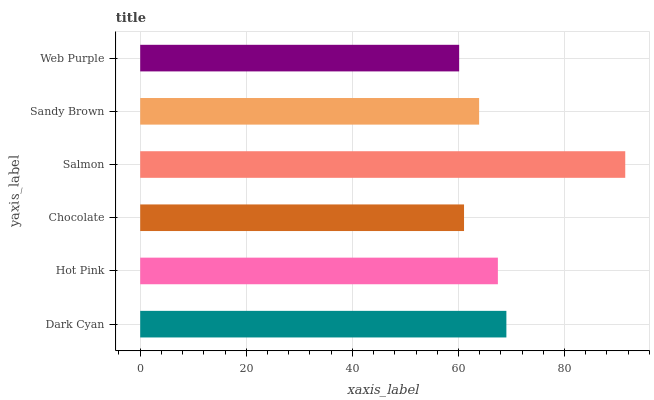Is Web Purple the minimum?
Answer yes or no. Yes. Is Salmon the maximum?
Answer yes or no. Yes. Is Hot Pink the minimum?
Answer yes or no. No. Is Hot Pink the maximum?
Answer yes or no. No. Is Dark Cyan greater than Hot Pink?
Answer yes or no. Yes. Is Hot Pink less than Dark Cyan?
Answer yes or no. Yes. Is Hot Pink greater than Dark Cyan?
Answer yes or no. No. Is Dark Cyan less than Hot Pink?
Answer yes or no. No. Is Hot Pink the high median?
Answer yes or no. Yes. Is Sandy Brown the low median?
Answer yes or no. Yes. Is Chocolate the high median?
Answer yes or no. No. Is Dark Cyan the low median?
Answer yes or no. No. 